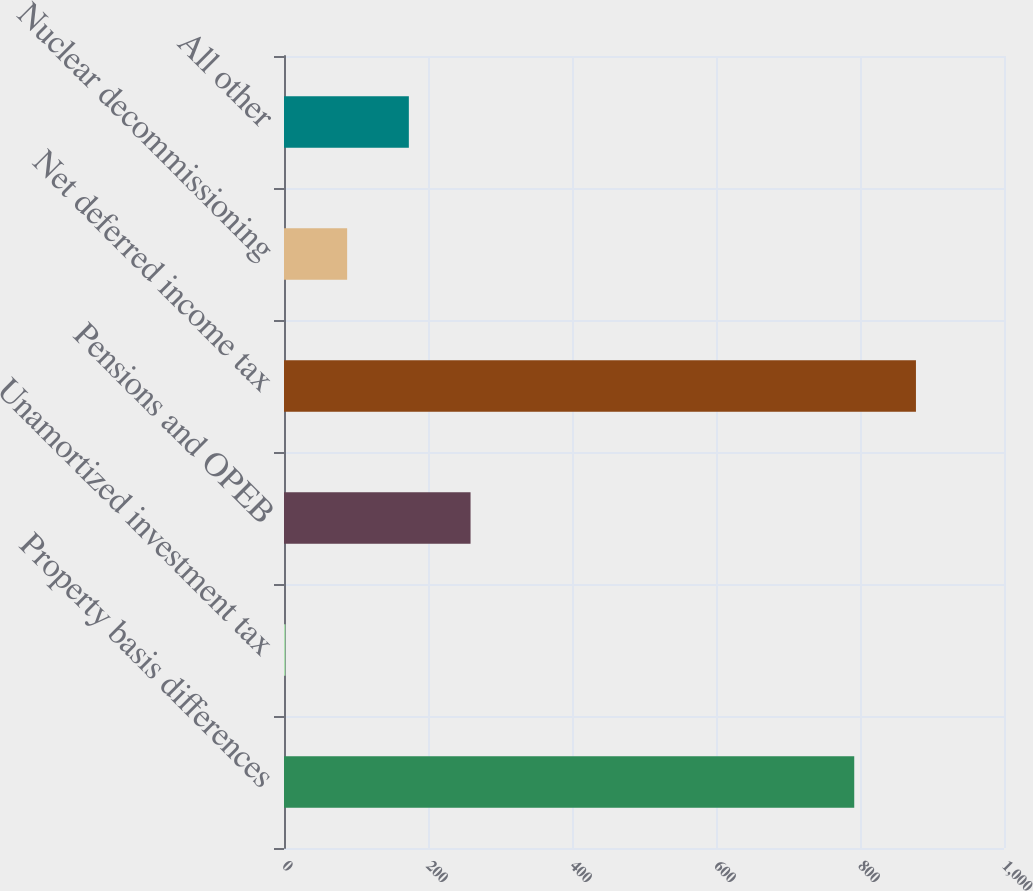Convert chart. <chart><loc_0><loc_0><loc_500><loc_500><bar_chart><fcel>Property basis differences<fcel>Unamortized investment tax<fcel>Pensions and OPEB<fcel>Net deferred income tax<fcel>Nuclear decommissioning<fcel>All other<nl><fcel>792<fcel>2<fcel>259.1<fcel>877.7<fcel>87.7<fcel>173.4<nl></chart> 